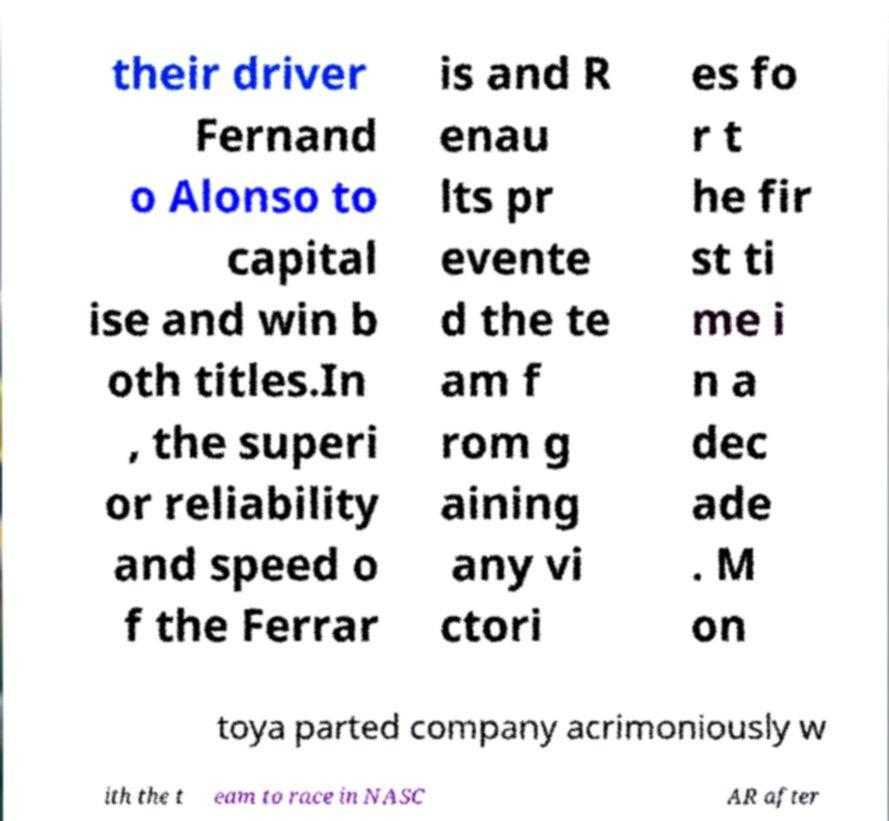Can you read and provide the text displayed in the image?This photo seems to have some interesting text. Can you extract and type it out for me? their driver Fernand o Alonso to capital ise and win b oth titles.In , the superi or reliability and speed o f the Ferrar is and R enau lts pr evente d the te am f rom g aining any vi ctori es fo r t he fir st ti me i n a dec ade . M on toya parted company acrimoniously w ith the t eam to race in NASC AR after 